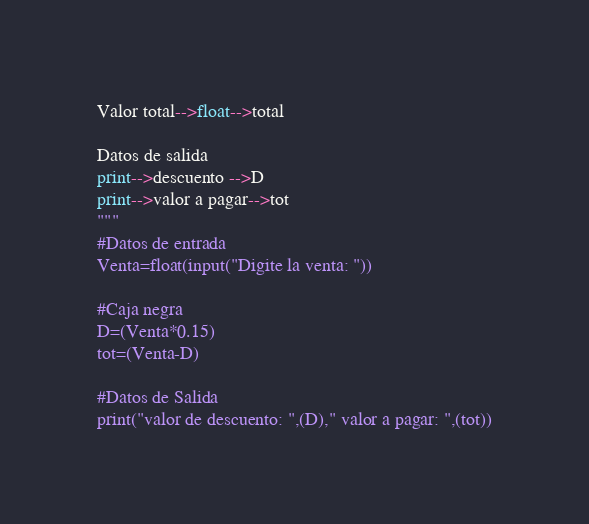Convert code to text. <code><loc_0><loc_0><loc_500><loc_500><_Python_>Valor total-->float-->total

Datos de salida
print-->descuento -->D
print-->valor a pagar-->tot
"""
#Datos de entrada
Venta=float(input("Digite la venta: "))

#Caja negra
D=(Venta*0.15)
tot=(Venta-D)

#Datos de Salida
print("valor de descuento: ",(D)," valor a pagar: ",(tot))</code> 